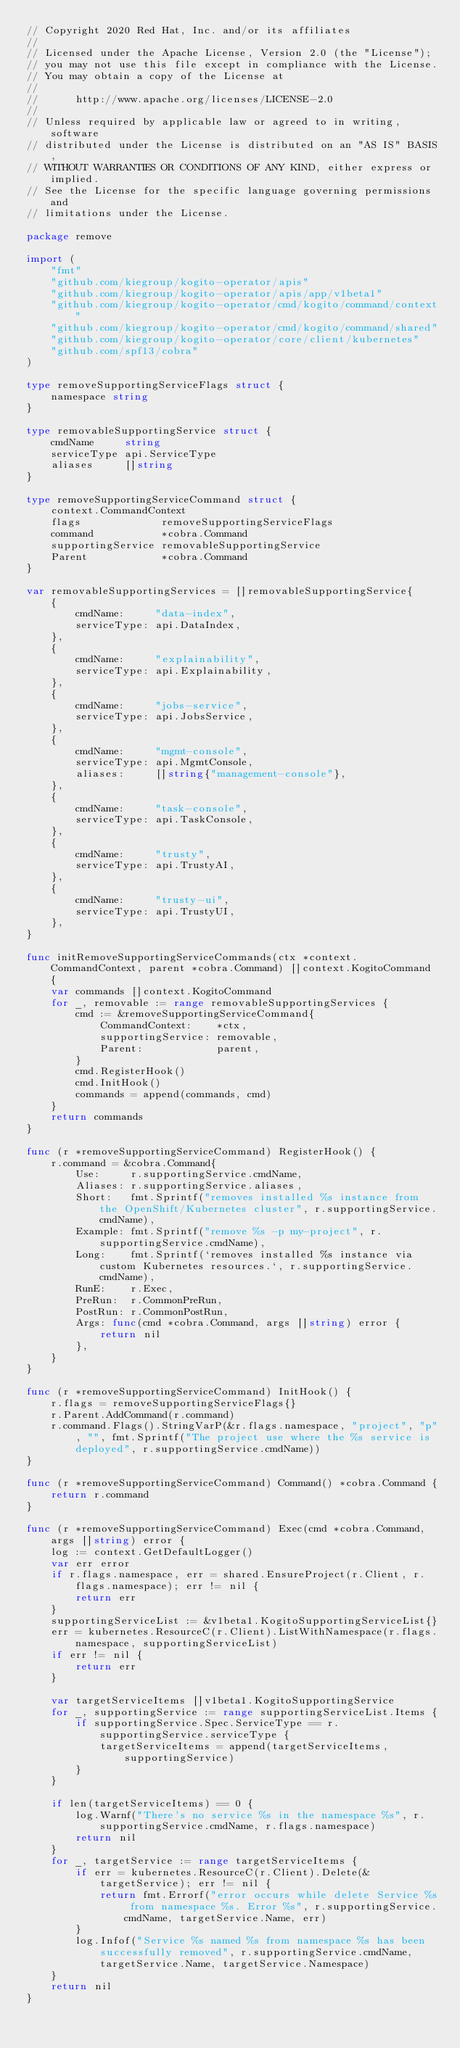Convert code to text. <code><loc_0><loc_0><loc_500><loc_500><_Go_>// Copyright 2020 Red Hat, Inc. and/or its affiliates
//
// Licensed under the Apache License, Version 2.0 (the "License");
// you may not use this file except in compliance with the License.
// You may obtain a copy of the License at
//
//      http://www.apache.org/licenses/LICENSE-2.0
//
// Unless required by applicable law or agreed to in writing, software
// distributed under the License is distributed on an "AS IS" BASIS,
// WITHOUT WARRANTIES OR CONDITIONS OF ANY KIND, either express or implied.
// See the License for the specific language governing permissions and
// limitations under the License.

package remove

import (
	"fmt"
	"github.com/kiegroup/kogito-operator/apis"
	"github.com/kiegroup/kogito-operator/apis/app/v1beta1"
	"github.com/kiegroup/kogito-operator/cmd/kogito/command/context"
	"github.com/kiegroup/kogito-operator/cmd/kogito/command/shared"
	"github.com/kiegroup/kogito-operator/core/client/kubernetes"
	"github.com/spf13/cobra"
)

type removeSupportingServiceFlags struct {
	namespace string
}

type removableSupportingService struct {
	cmdName     string
	serviceType api.ServiceType
	aliases     []string
}

type removeSupportingServiceCommand struct {
	context.CommandContext
	flags             removeSupportingServiceFlags
	command           *cobra.Command
	supportingService removableSupportingService
	Parent            *cobra.Command
}

var removableSupportingServices = []removableSupportingService{
	{
		cmdName:     "data-index",
		serviceType: api.DataIndex,
	},
	{
		cmdName:     "explainability",
		serviceType: api.Explainability,
	},
	{
		cmdName:     "jobs-service",
		serviceType: api.JobsService,
	},
	{
		cmdName:     "mgmt-console",
		serviceType: api.MgmtConsole,
		aliases:     []string{"management-console"},
	},
	{
		cmdName:     "task-console",
		serviceType: api.TaskConsole,
	},
	{
		cmdName:     "trusty",
		serviceType: api.TrustyAI,
	},
	{
		cmdName:     "trusty-ui",
		serviceType: api.TrustyUI,
	},
}

func initRemoveSupportingServiceCommands(ctx *context.CommandContext, parent *cobra.Command) []context.KogitoCommand {
	var commands []context.KogitoCommand
	for _, removable := range removableSupportingServices {
		cmd := &removeSupportingServiceCommand{
			CommandContext:    *ctx,
			supportingService: removable,
			Parent:            parent,
		}
		cmd.RegisterHook()
		cmd.InitHook()
		commands = append(commands, cmd)
	}
	return commands
}

func (r *removeSupportingServiceCommand) RegisterHook() {
	r.command = &cobra.Command{
		Use:     r.supportingService.cmdName,
		Aliases: r.supportingService.aliases,
		Short:   fmt.Sprintf("removes installed %s instance from the OpenShift/Kubernetes cluster", r.supportingService.cmdName),
		Example: fmt.Sprintf("remove %s -p my-project", r.supportingService.cmdName),
		Long:    fmt.Sprintf(`removes installed %s instance via custom Kubernetes resources.`, r.supportingService.cmdName),
		RunE:    r.Exec,
		PreRun:  r.CommonPreRun,
		PostRun: r.CommonPostRun,
		Args: func(cmd *cobra.Command, args []string) error {
			return nil
		},
	}
}

func (r *removeSupportingServiceCommand) InitHook() {
	r.flags = removeSupportingServiceFlags{}
	r.Parent.AddCommand(r.command)
	r.command.Flags().StringVarP(&r.flags.namespace, "project", "p", "", fmt.Sprintf("The project use where the %s service is deployed", r.supportingService.cmdName))
}

func (r *removeSupportingServiceCommand) Command() *cobra.Command {
	return r.command
}

func (r *removeSupportingServiceCommand) Exec(cmd *cobra.Command, args []string) error {
	log := context.GetDefaultLogger()
	var err error
	if r.flags.namespace, err = shared.EnsureProject(r.Client, r.flags.namespace); err != nil {
		return err
	}
	supportingServiceList := &v1beta1.KogitoSupportingServiceList{}
	err = kubernetes.ResourceC(r.Client).ListWithNamespace(r.flags.namespace, supportingServiceList)
	if err != nil {
		return err
	}

	var targetServiceItems []v1beta1.KogitoSupportingService
	for _, supportingService := range supportingServiceList.Items {
		if supportingService.Spec.ServiceType == r.supportingService.serviceType {
			targetServiceItems = append(targetServiceItems, supportingService)
		}
	}

	if len(targetServiceItems) == 0 {
		log.Warnf("There's no service %s in the namespace %s", r.supportingService.cmdName, r.flags.namespace)
		return nil
	}
	for _, targetService := range targetServiceItems {
		if err = kubernetes.ResourceC(r.Client).Delete(&targetService); err != nil {
			return fmt.Errorf("error occurs while delete Service %s from namespace %s. Error %s", r.supportingService.cmdName, targetService.Name, err)
		}
		log.Infof("Service %s named %s from namespace %s has been successfully removed", r.supportingService.cmdName, targetService.Name, targetService.Namespace)
	}
	return nil
}
</code> 